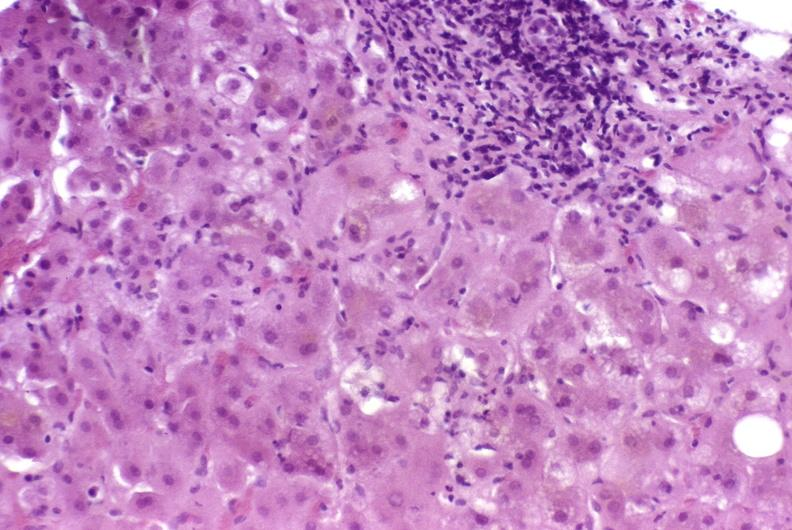s hepatobiliary present?
Answer the question using a single word or phrase. Yes 